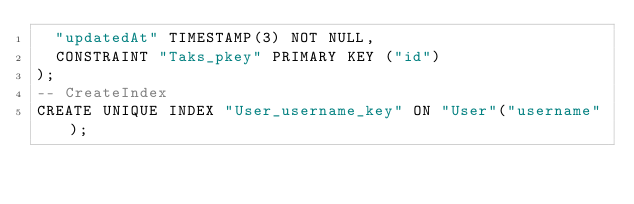<code> <loc_0><loc_0><loc_500><loc_500><_SQL_>  "updatedAt" TIMESTAMP(3) NOT NULL,
  CONSTRAINT "Taks_pkey" PRIMARY KEY ("id")
);
-- CreateIndex
CREATE UNIQUE INDEX "User_username_key" ON "User"("username");</code> 